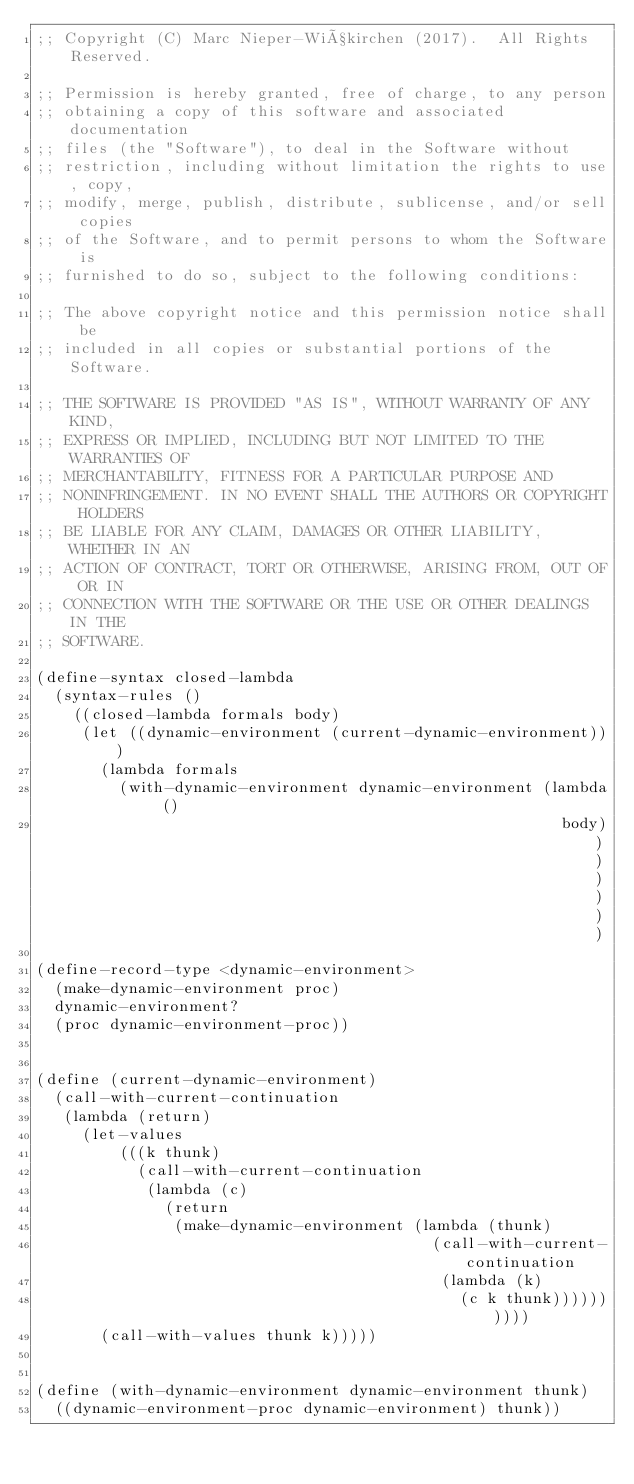Convert code to text. <code><loc_0><loc_0><loc_500><loc_500><_Scheme_>;; Copyright (C) Marc Nieper-Wißkirchen (2017).  All Rights Reserved.

;; Permission is hereby granted, free of charge, to any person
;; obtaining a copy of this software and associated documentation
;; files (the "Software"), to deal in the Software without
;; restriction, including without limitation the rights to use, copy,
;; modify, merge, publish, distribute, sublicense, and/or sell copies
;; of the Software, and to permit persons to whom the Software is
;; furnished to do so, subject to the following conditions:

;; The above copyright notice and this permission notice shall be
;; included in all copies or substantial portions of the Software.

;; THE SOFTWARE IS PROVIDED "AS IS", WITHOUT WARRANTY OF ANY KIND,
;; EXPRESS OR IMPLIED, INCLUDING BUT NOT LIMITED TO THE WARRANTIES OF
;; MERCHANTABILITY, FITNESS FOR A PARTICULAR PURPOSE AND
;; NONINFRINGEMENT. IN NO EVENT SHALL THE AUTHORS OR COPYRIGHT HOLDERS
;; BE LIABLE FOR ANY CLAIM, DAMAGES OR OTHER LIABILITY, WHETHER IN AN
;; ACTION OF CONTRACT, TORT OR OTHERWISE, ARISING FROM, OUT OF OR IN
;; CONNECTION WITH THE SOFTWARE OR THE USE OR OTHER DEALINGS IN THE
;; SOFTWARE.

(define-syntax closed-lambda
  (syntax-rules ()
    ((closed-lambda formals body)
     (let ((dynamic-environment (current-dynamic-environment)))
       (lambda formals
         (with-dynamic-environment dynamic-environment (lambda ()
                                                         body)))))))

(define-record-type <dynamic-environment>
  (make-dynamic-environment proc)
  dynamic-environment?
  (proc dynamic-environment-proc))


(define (current-dynamic-environment)
  (call-with-current-continuation
   (lambda (return)
     (let-values
         (((k thunk)
           (call-with-current-continuation
            (lambda (c)
              (return
               (make-dynamic-environment (lambda (thunk)
                                           (call-with-current-continuation
                                            (lambda (k)
                                              (c k thunk))))))))))
       (call-with-values thunk k)))))


(define (with-dynamic-environment dynamic-environment thunk)
  ((dynamic-environment-proc dynamic-environment) thunk))
</code> 